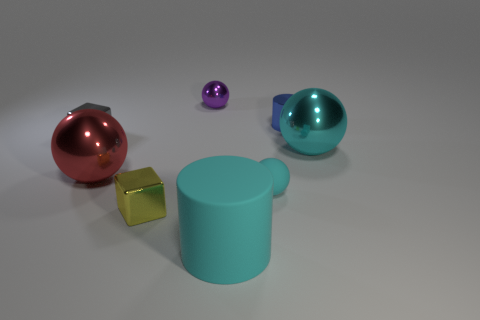Add 2 small gray shiny spheres. How many objects exist? 10 Subtract all cylinders. How many objects are left? 6 Add 6 cyan rubber things. How many cyan rubber things are left? 8 Add 7 tiny metallic cylinders. How many tiny metallic cylinders exist? 8 Subtract 1 blue cylinders. How many objects are left? 7 Subtract all spheres. Subtract all large brown rubber things. How many objects are left? 4 